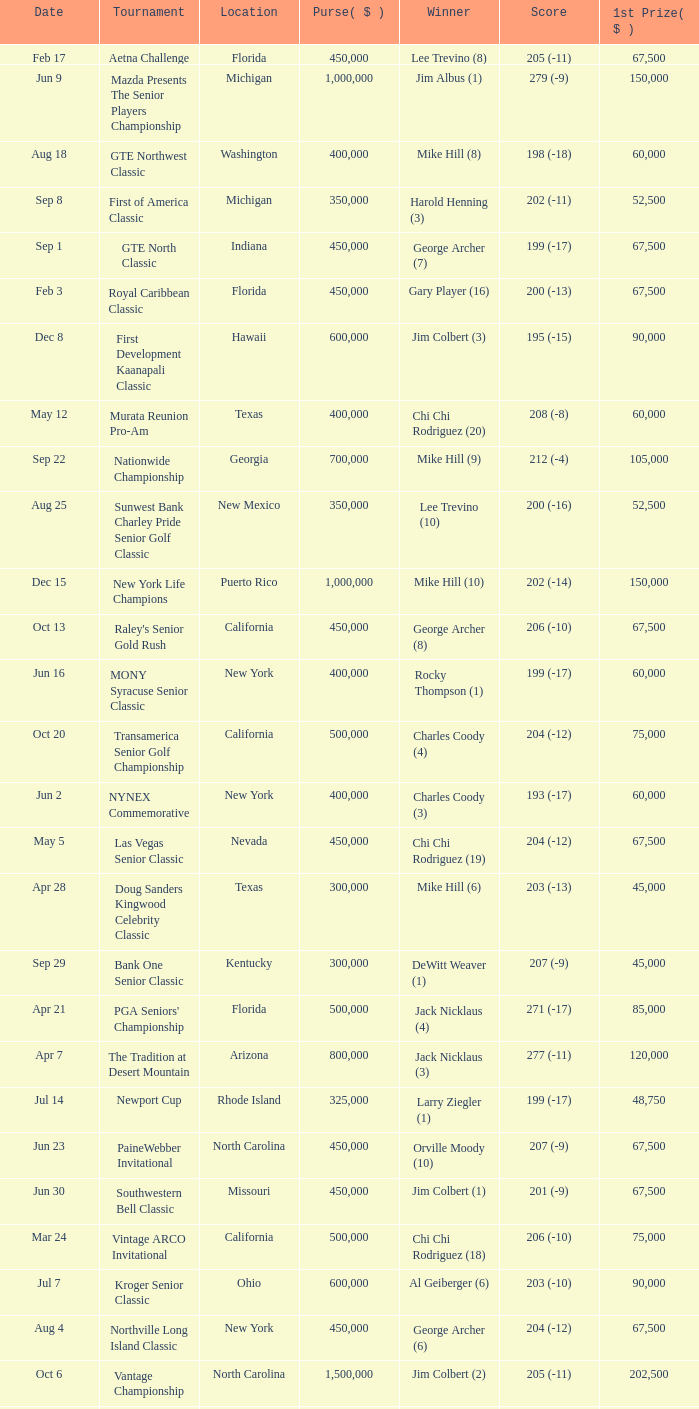What is the purse for the tournament with a winning score of 212 (-4), and a 1st prize of under $105,000? None. 